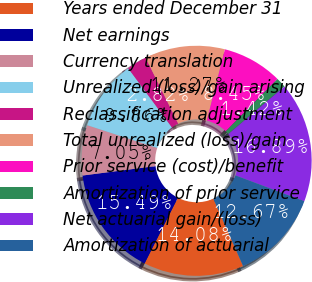<chart> <loc_0><loc_0><loc_500><loc_500><pie_chart><fcel>Years ended December 31<fcel>Net earnings<fcel>Currency translation<fcel>Unrealized (loss)/gain arising<fcel>Reclassification adjustment<fcel>Total unrealized (loss)/gain<fcel>Prior service (cost)/benefit<fcel>Amortization of prior service<fcel>Net actuarial gain/(loss)<fcel>Amortization of actuarial<nl><fcel>14.08%<fcel>15.49%<fcel>7.05%<fcel>9.86%<fcel>2.82%<fcel>11.27%<fcel>8.45%<fcel>1.42%<fcel>16.89%<fcel>12.67%<nl></chart> 